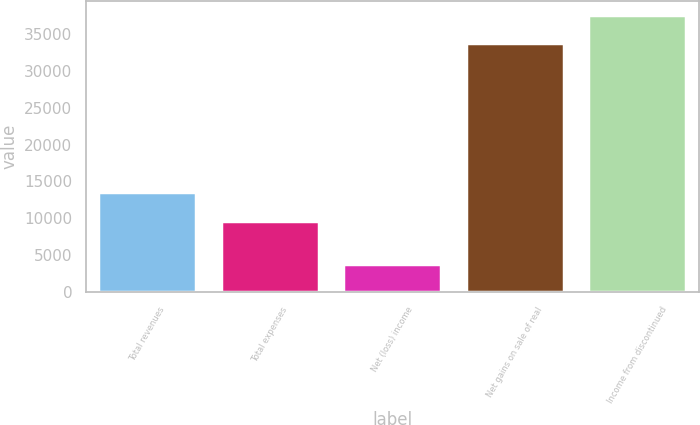Convert chart. <chart><loc_0><loc_0><loc_500><loc_500><bar_chart><fcel>Total revenues<fcel>Total expenses<fcel>Net (loss) income<fcel>Net gains on sale of real<fcel>Income from discontinued<nl><fcel>13522<fcel>9696<fcel>3826<fcel>33769<fcel>37595<nl></chart> 